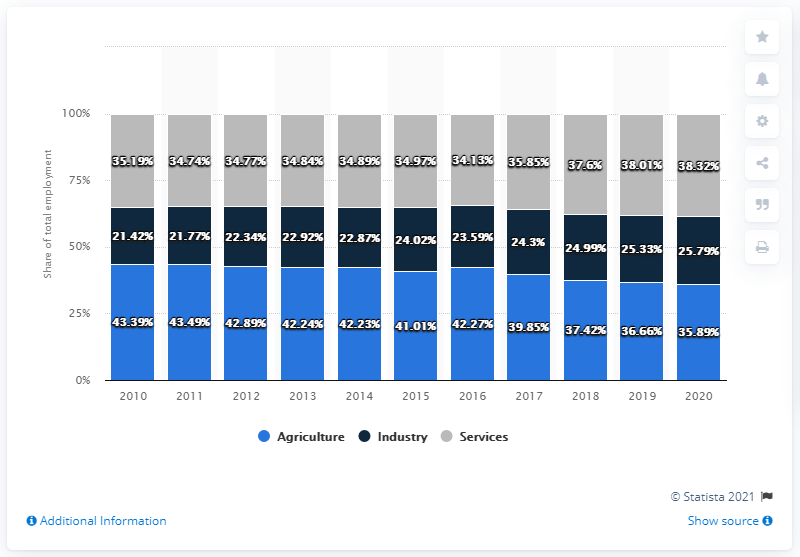Highlight a few significant elements in this photo. In 2020, the sector with the highest employment in percentage terms was services. In 2014, the agriculture sector accounted for 42.23% of total employment. 